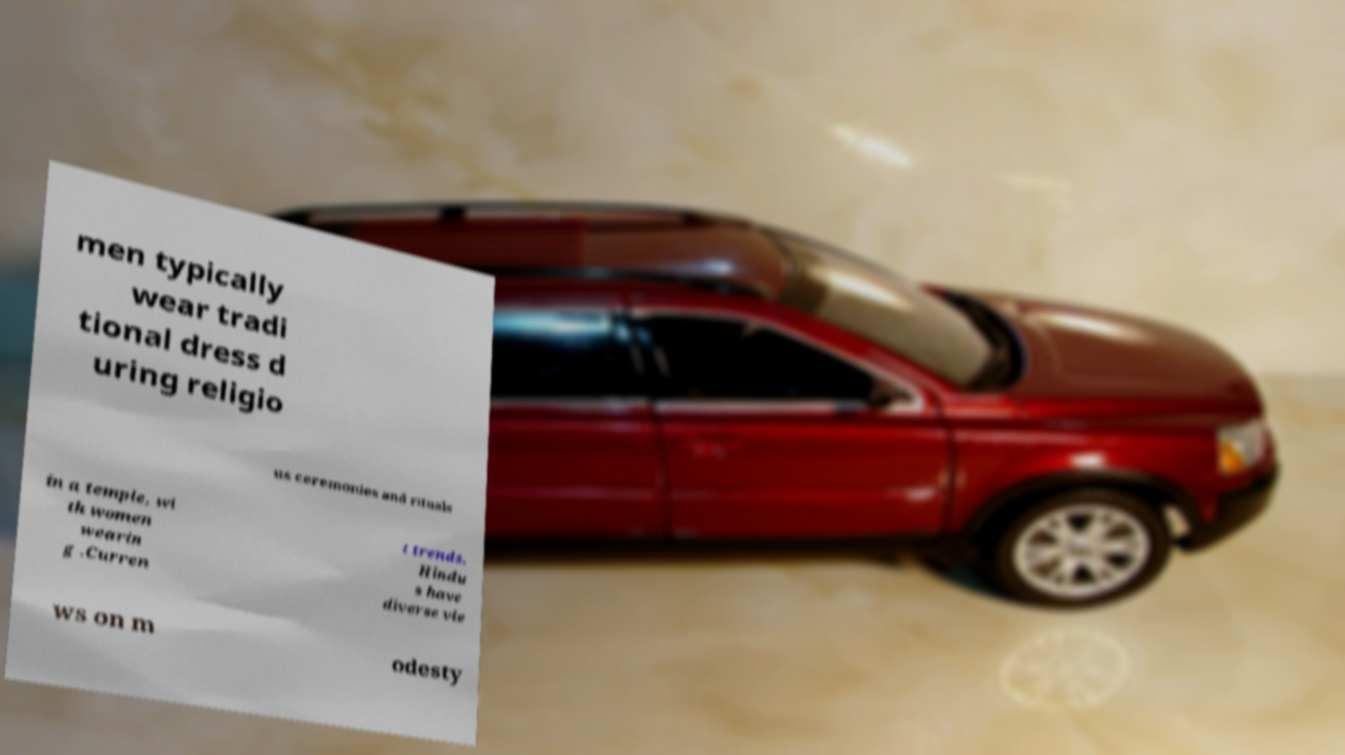Please identify and transcribe the text found in this image. men typically wear tradi tional dress d uring religio us ceremonies and rituals in a temple, wi th women wearin g .Curren t trends. Hindu s have diverse vie ws on m odesty 